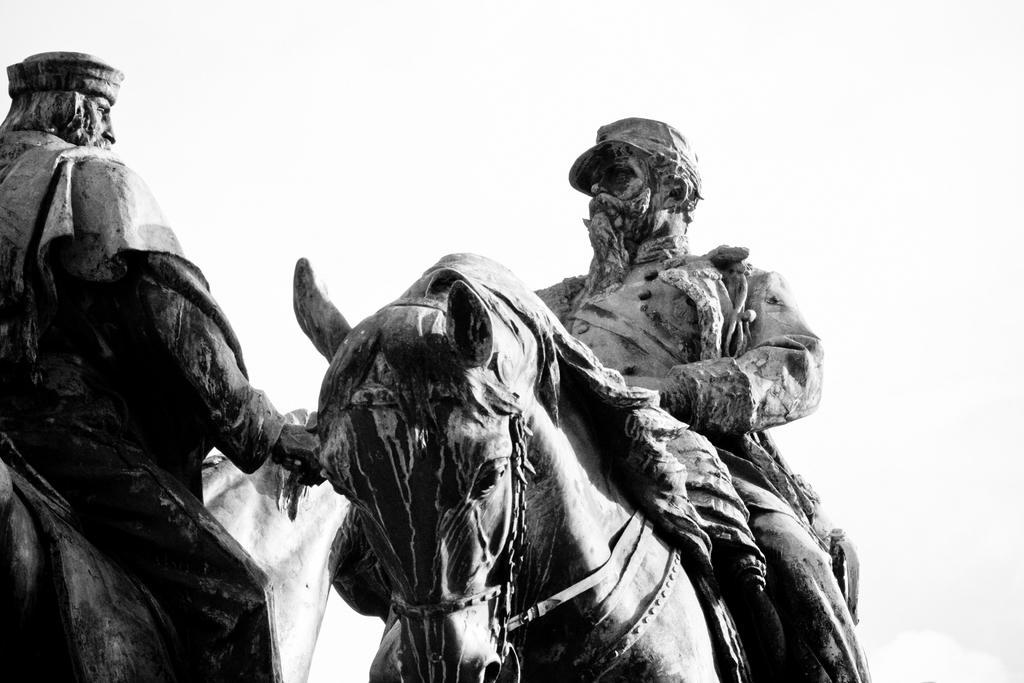Could you give a brief overview of what you see in this image? In this picture a person is sitting on a horse, he is waving his hand, with another person. he has a cap and a beard ,and it is a statue. 